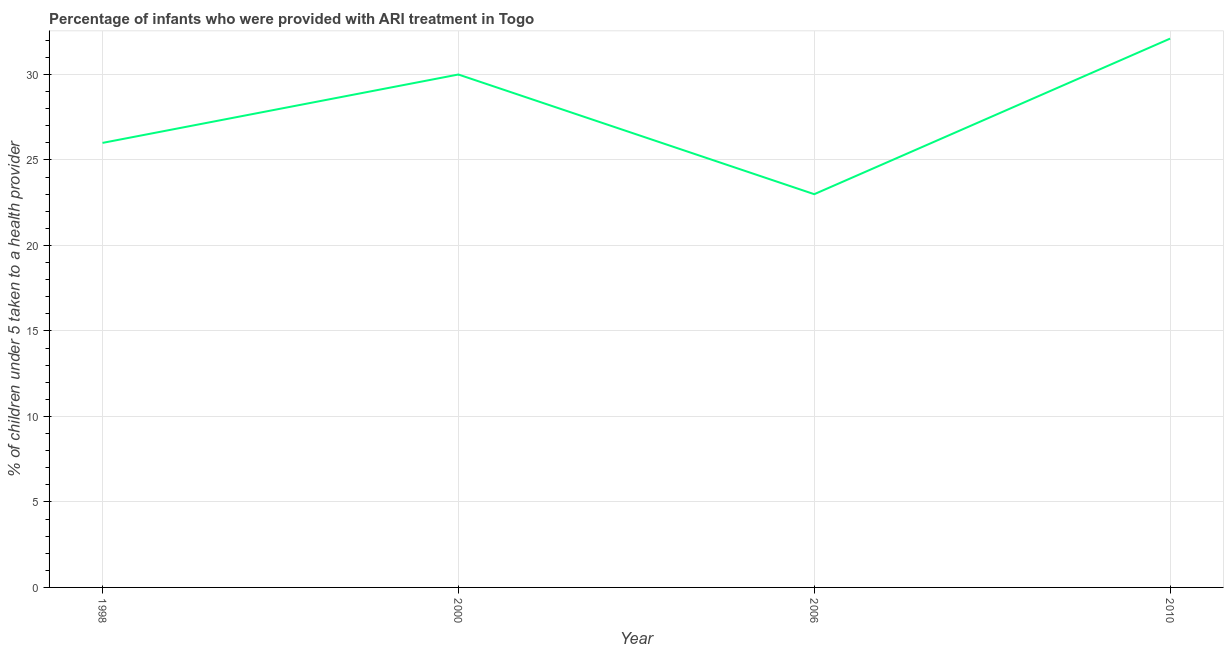Across all years, what is the maximum percentage of children who were provided with ari treatment?
Your response must be concise. 32.1. Across all years, what is the minimum percentage of children who were provided with ari treatment?
Your answer should be compact. 23. What is the sum of the percentage of children who were provided with ari treatment?
Offer a very short reply. 111.1. What is the difference between the percentage of children who were provided with ari treatment in 2006 and 2010?
Offer a terse response. -9.1. What is the average percentage of children who were provided with ari treatment per year?
Provide a succinct answer. 27.77. What is the median percentage of children who were provided with ari treatment?
Make the answer very short. 28. Do a majority of the years between 2010 and 2006 (inclusive) have percentage of children who were provided with ari treatment greater than 29 %?
Your response must be concise. No. What is the ratio of the percentage of children who were provided with ari treatment in 2000 to that in 2006?
Offer a terse response. 1.3. Is the percentage of children who were provided with ari treatment in 2000 less than that in 2010?
Provide a succinct answer. Yes. Is the difference between the percentage of children who were provided with ari treatment in 2000 and 2010 greater than the difference between any two years?
Make the answer very short. No. What is the difference between the highest and the second highest percentage of children who were provided with ari treatment?
Provide a short and direct response. 2.1. What is the difference between the highest and the lowest percentage of children who were provided with ari treatment?
Make the answer very short. 9.1. Does the percentage of children who were provided with ari treatment monotonically increase over the years?
Offer a terse response. No. How many years are there in the graph?
Your answer should be compact. 4. Are the values on the major ticks of Y-axis written in scientific E-notation?
Give a very brief answer. No. What is the title of the graph?
Give a very brief answer. Percentage of infants who were provided with ARI treatment in Togo. What is the label or title of the Y-axis?
Keep it short and to the point. % of children under 5 taken to a health provider. What is the % of children under 5 taken to a health provider of 1998?
Give a very brief answer. 26. What is the % of children under 5 taken to a health provider of 2000?
Offer a terse response. 30. What is the % of children under 5 taken to a health provider of 2010?
Give a very brief answer. 32.1. What is the difference between the % of children under 5 taken to a health provider in 2000 and 2010?
Provide a succinct answer. -2.1. What is the difference between the % of children under 5 taken to a health provider in 2006 and 2010?
Your response must be concise. -9.1. What is the ratio of the % of children under 5 taken to a health provider in 1998 to that in 2000?
Offer a very short reply. 0.87. What is the ratio of the % of children under 5 taken to a health provider in 1998 to that in 2006?
Your answer should be compact. 1.13. What is the ratio of the % of children under 5 taken to a health provider in 1998 to that in 2010?
Offer a terse response. 0.81. What is the ratio of the % of children under 5 taken to a health provider in 2000 to that in 2006?
Provide a short and direct response. 1.3. What is the ratio of the % of children under 5 taken to a health provider in 2000 to that in 2010?
Your answer should be compact. 0.94. What is the ratio of the % of children under 5 taken to a health provider in 2006 to that in 2010?
Your response must be concise. 0.72. 